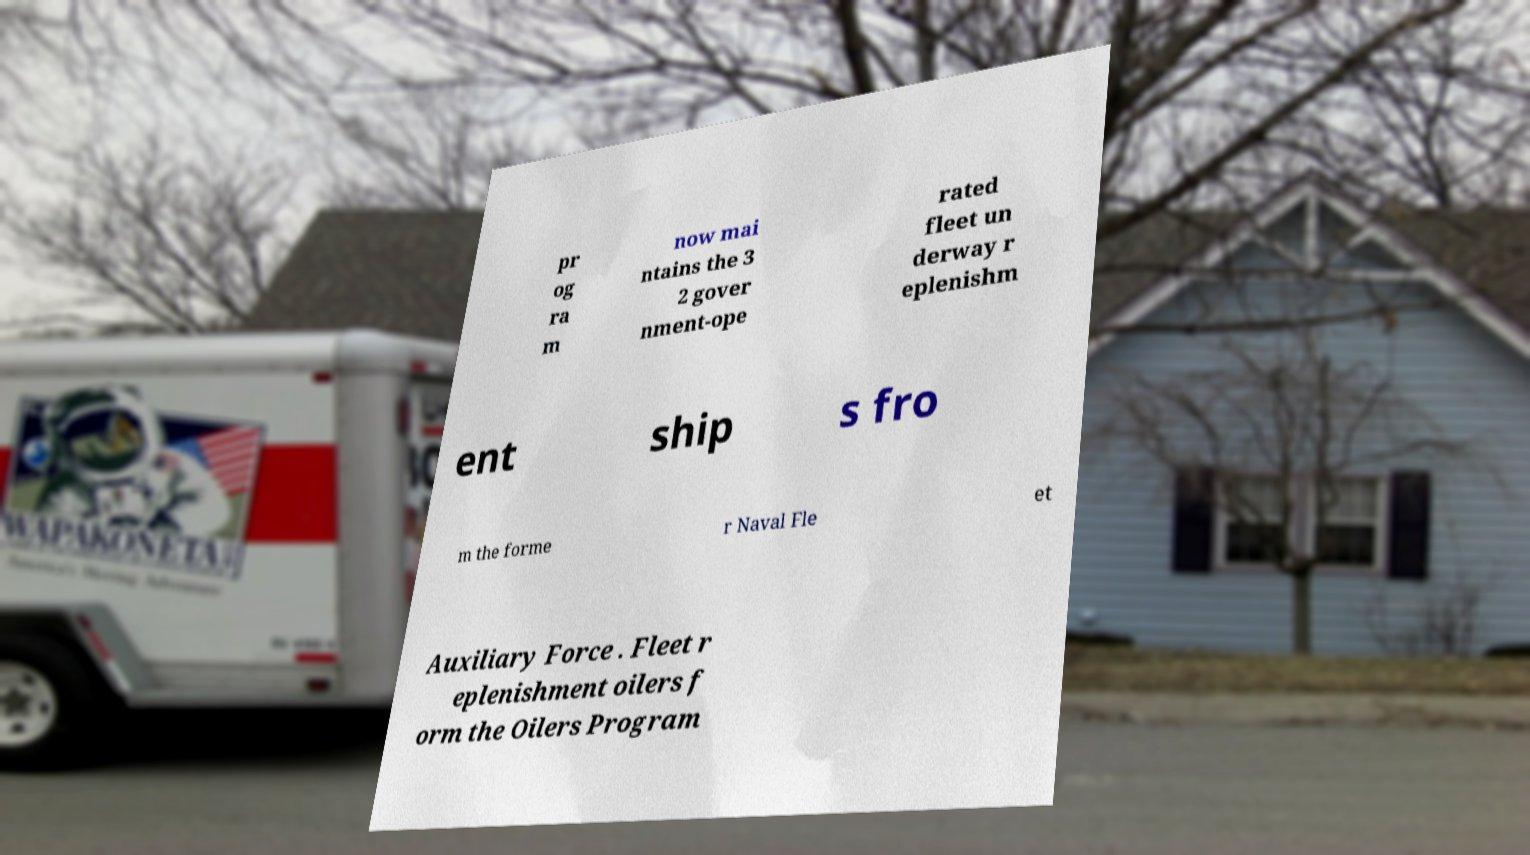What messages or text are displayed in this image? I need them in a readable, typed format. pr og ra m now mai ntains the 3 2 gover nment-ope rated fleet un derway r eplenishm ent ship s fro m the forme r Naval Fle et Auxiliary Force . Fleet r eplenishment oilers f orm the Oilers Program 